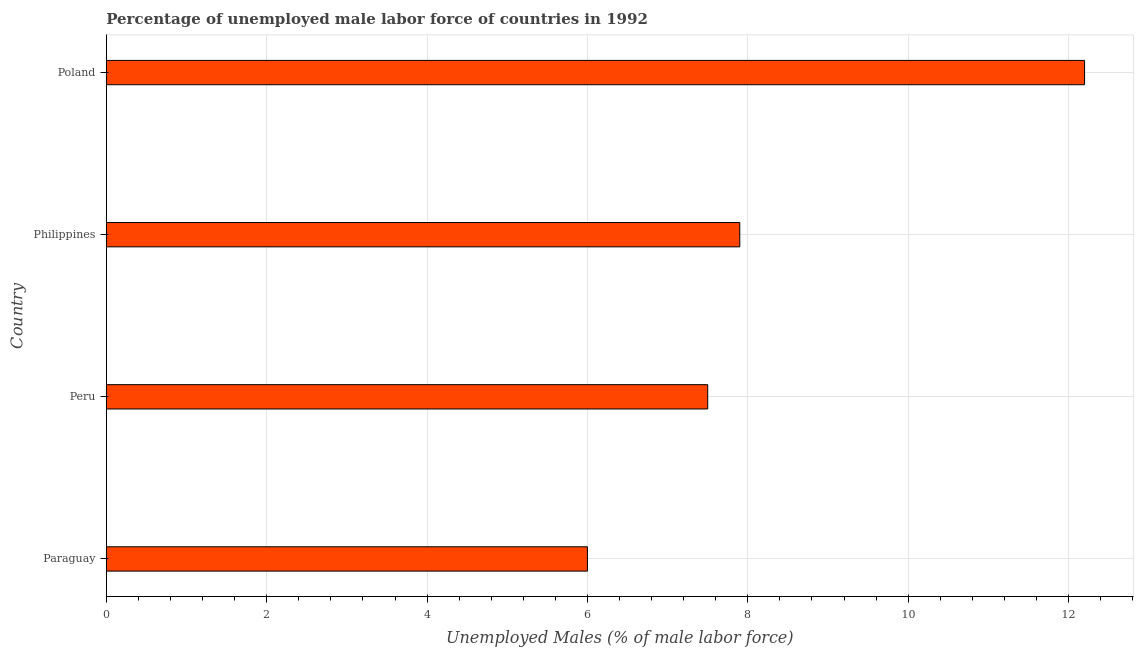What is the title of the graph?
Offer a very short reply. Percentage of unemployed male labor force of countries in 1992. What is the label or title of the X-axis?
Offer a terse response. Unemployed Males (% of male labor force). What is the label or title of the Y-axis?
Make the answer very short. Country. What is the total unemployed male labour force in Philippines?
Give a very brief answer. 7.9. Across all countries, what is the maximum total unemployed male labour force?
Provide a succinct answer. 12.2. Across all countries, what is the minimum total unemployed male labour force?
Provide a succinct answer. 6. In which country was the total unemployed male labour force maximum?
Give a very brief answer. Poland. In which country was the total unemployed male labour force minimum?
Offer a very short reply. Paraguay. What is the sum of the total unemployed male labour force?
Make the answer very short. 33.6. What is the difference between the total unemployed male labour force in Paraguay and Poland?
Your response must be concise. -6.2. What is the median total unemployed male labour force?
Make the answer very short. 7.7. In how many countries, is the total unemployed male labour force greater than 11.6 %?
Provide a short and direct response. 1. What is the ratio of the total unemployed male labour force in Philippines to that in Poland?
Your answer should be very brief. 0.65. Is the total unemployed male labour force in Paraguay less than that in Peru?
Keep it short and to the point. Yes. Is the difference between the total unemployed male labour force in Paraguay and Philippines greater than the difference between any two countries?
Your answer should be very brief. No. What is the difference between the highest and the second highest total unemployed male labour force?
Make the answer very short. 4.3. What is the difference between the highest and the lowest total unemployed male labour force?
Keep it short and to the point. 6.2. Are all the bars in the graph horizontal?
Offer a very short reply. Yes. What is the Unemployed Males (% of male labor force) of Paraguay?
Offer a terse response. 6. What is the Unemployed Males (% of male labor force) in Peru?
Your answer should be compact. 7.5. What is the Unemployed Males (% of male labor force) of Philippines?
Keep it short and to the point. 7.9. What is the Unemployed Males (% of male labor force) in Poland?
Offer a terse response. 12.2. What is the difference between the Unemployed Males (% of male labor force) in Paraguay and Philippines?
Keep it short and to the point. -1.9. What is the difference between the Unemployed Males (% of male labor force) in Paraguay and Poland?
Provide a short and direct response. -6.2. What is the difference between the Unemployed Males (% of male labor force) in Peru and Poland?
Offer a very short reply. -4.7. What is the ratio of the Unemployed Males (% of male labor force) in Paraguay to that in Peru?
Give a very brief answer. 0.8. What is the ratio of the Unemployed Males (% of male labor force) in Paraguay to that in Philippines?
Ensure brevity in your answer.  0.76. What is the ratio of the Unemployed Males (% of male labor force) in Paraguay to that in Poland?
Your answer should be compact. 0.49. What is the ratio of the Unemployed Males (% of male labor force) in Peru to that in Philippines?
Give a very brief answer. 0.95. What is the ratio of the Unemployed Males (% of male labor force) in Peru to that in Poland?
Ensure brevity in your answer.  0.61. What is the ratio of the Unemployed Males (% of male labor force) in Philippines to that in Poland?
Provide a succinct answer. 0.65. 